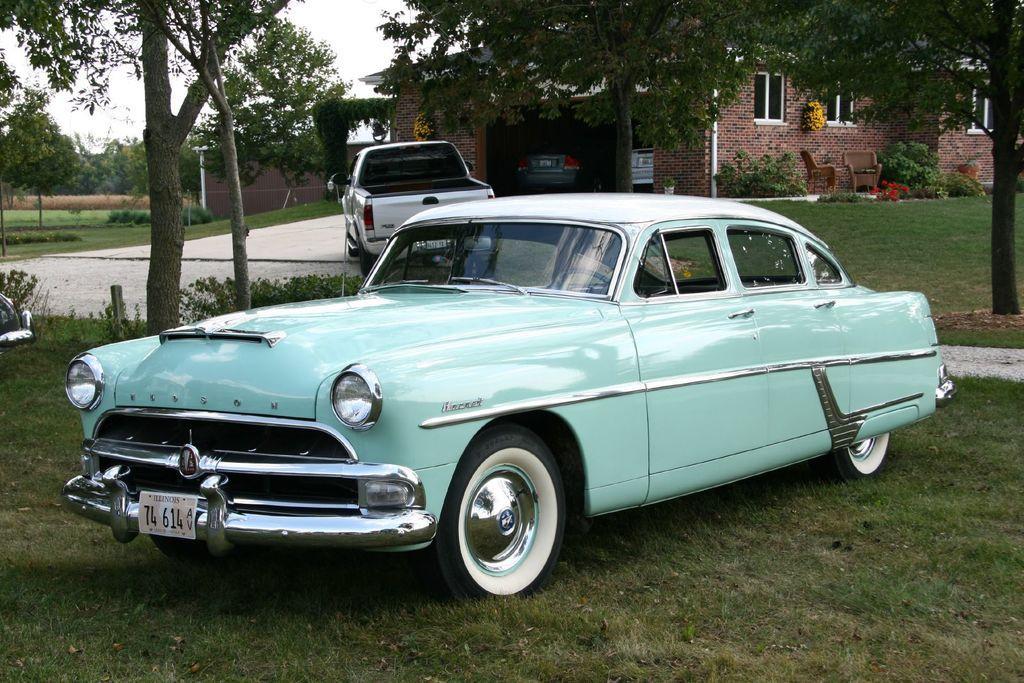Can you describe this image briefly? In the image I can see a place where we have a car and behind there is a house, some cars and around there are some trees and plants. 